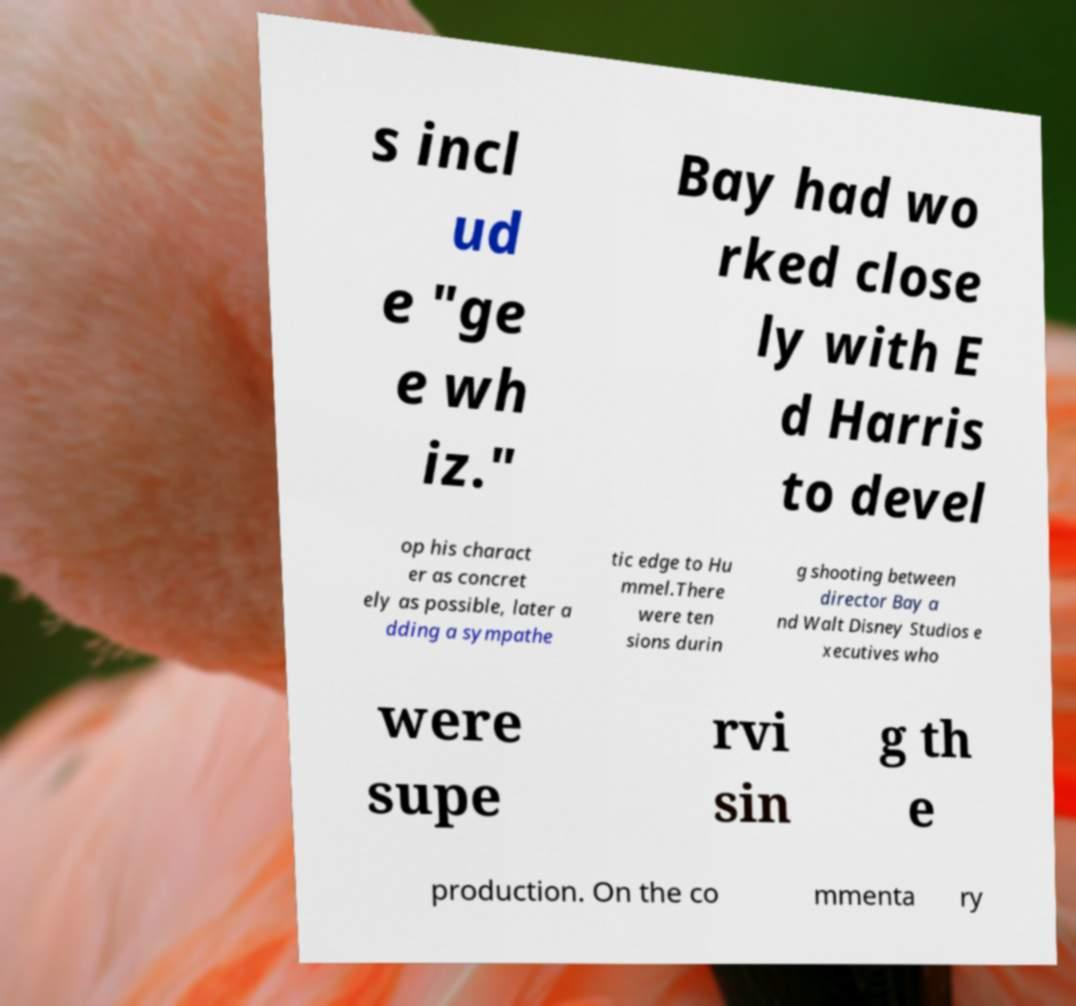There's text embedded in this image that I need extracted. Can you transcribe it verbatim? s incl ud e "ge e wh iz." Bay had wo rked close ly with E d Harris to devel op his charact er as concret ely as possible, later a dding a sympathe tic edge to Hu mmel.There were ten sions durin g shooting between director Bay a nd Walt Disney Studios e xecutives who were supe rvi sin g th e production. On the co mmenta ry 